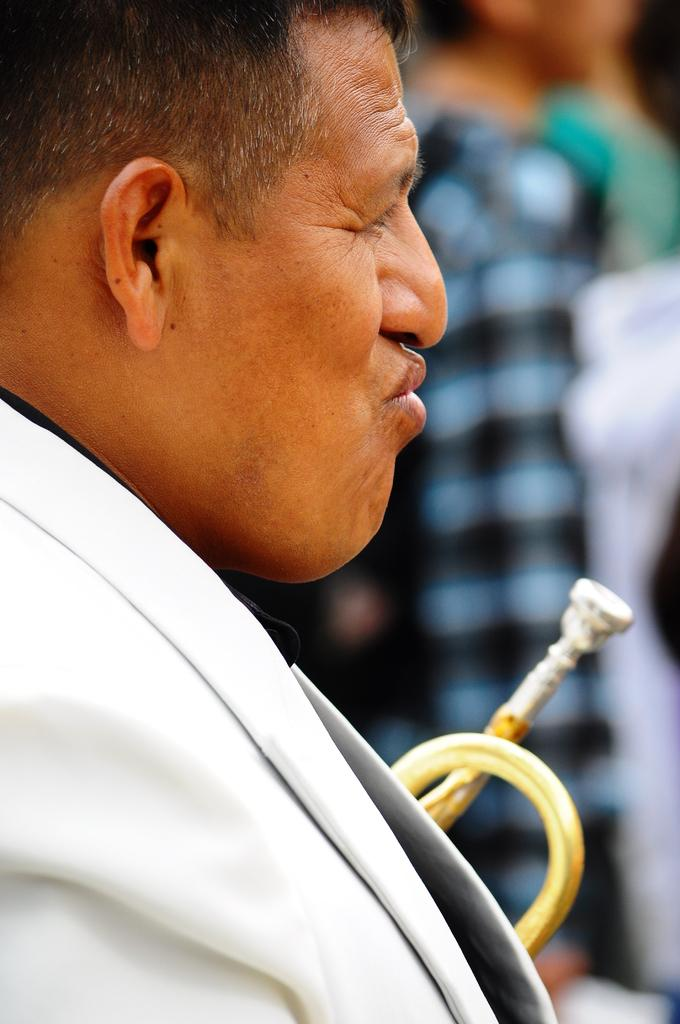What is the main subject of the image? There is a person in the image. What is the person wearing? The person is wearing a white dress. Can you describe the background of the image? The background of the image is blurred. What type of joke is the rat telling in the image? There is no rat present in the image, and therefore no such activity can be observed. 